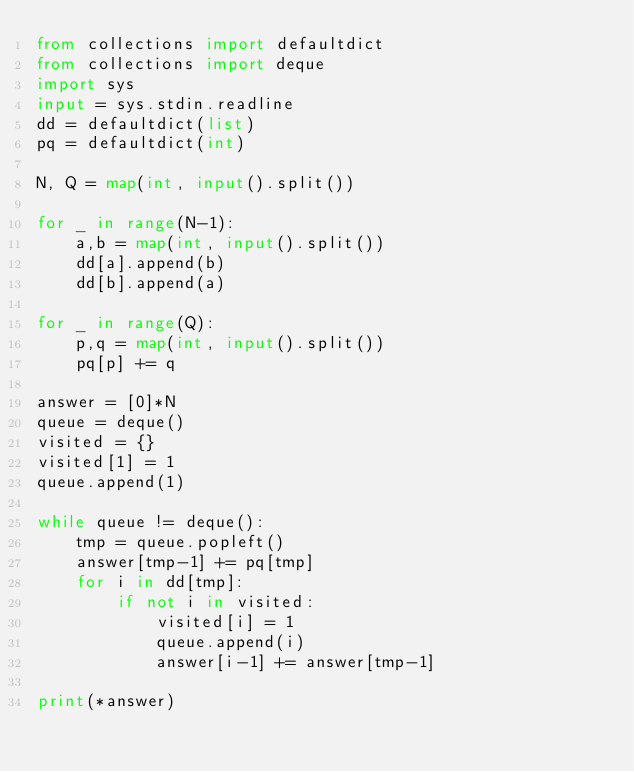Convert code to text. <code><loc_0><loc_0><loc_500><loc_500><_Python_>from collections import defaultdict
from collections import deque
import sys
input = sys.stdin.readline
dd = defaultdict(list)
pq = defaultdict(int)
 
N, Q = map(int, input().split())
 
for _ in range(N-1):
    a,b = map(int, input().split())
    dd[a].append(b)
    dd[b].append(a)
 
for _ in range(Q):
    p,q = map(int, input().split())
    pq[p] += q
    
answer = [0]*N
queue = deque()
visited = {}
visited[1] = 1
queue.append(1)
 
while queue != deque():
    tmp = queue.popleft()
    answer[tmp-1] += pq[tmp]
    for i in dd[tmp]:
        if not i in visited:
            visited[i] = 1
            queue.append(i)
            answer[i-1] += answer[tmp-1]
            
print(*answer)</code> 